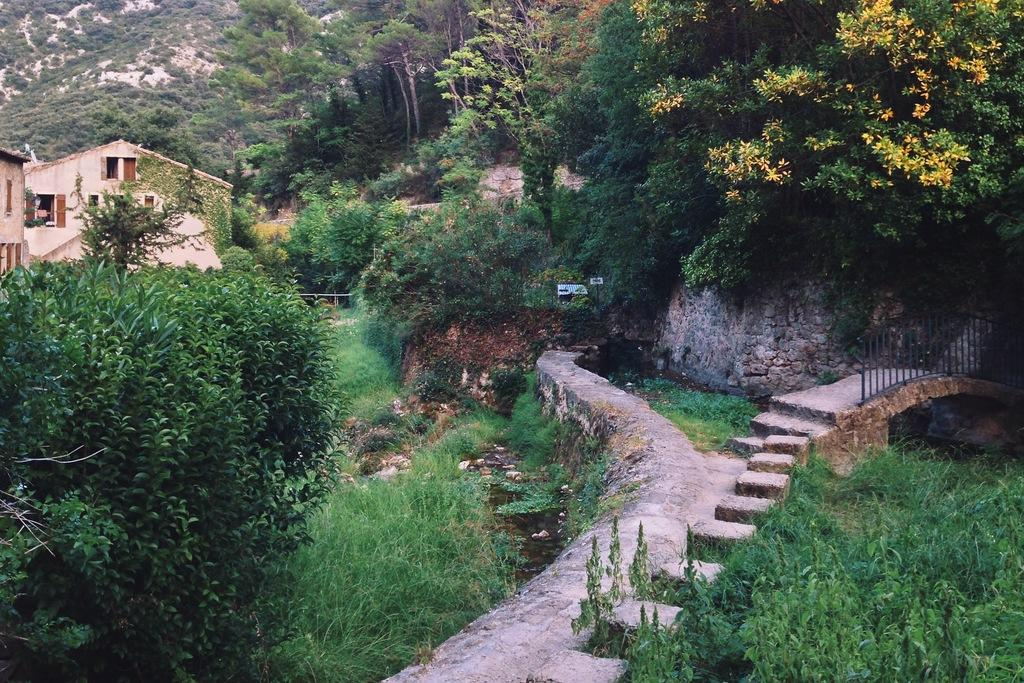What type of natural elements can be seen in the image? There are trees in the image. What type of man-made structures are present in the image? There are houses in the image. What type of fence can be seen on the right side of the image? There is a metal rod fence on the right side of the image. What part of the brain is visible in the image? There is no brain visible in the image; it features trees, houses, and a metal rod fence. What type of pain can be seen in the image? There is no pain visible in the image; it is a photograph of trees, houses, and a metal rod fence. 